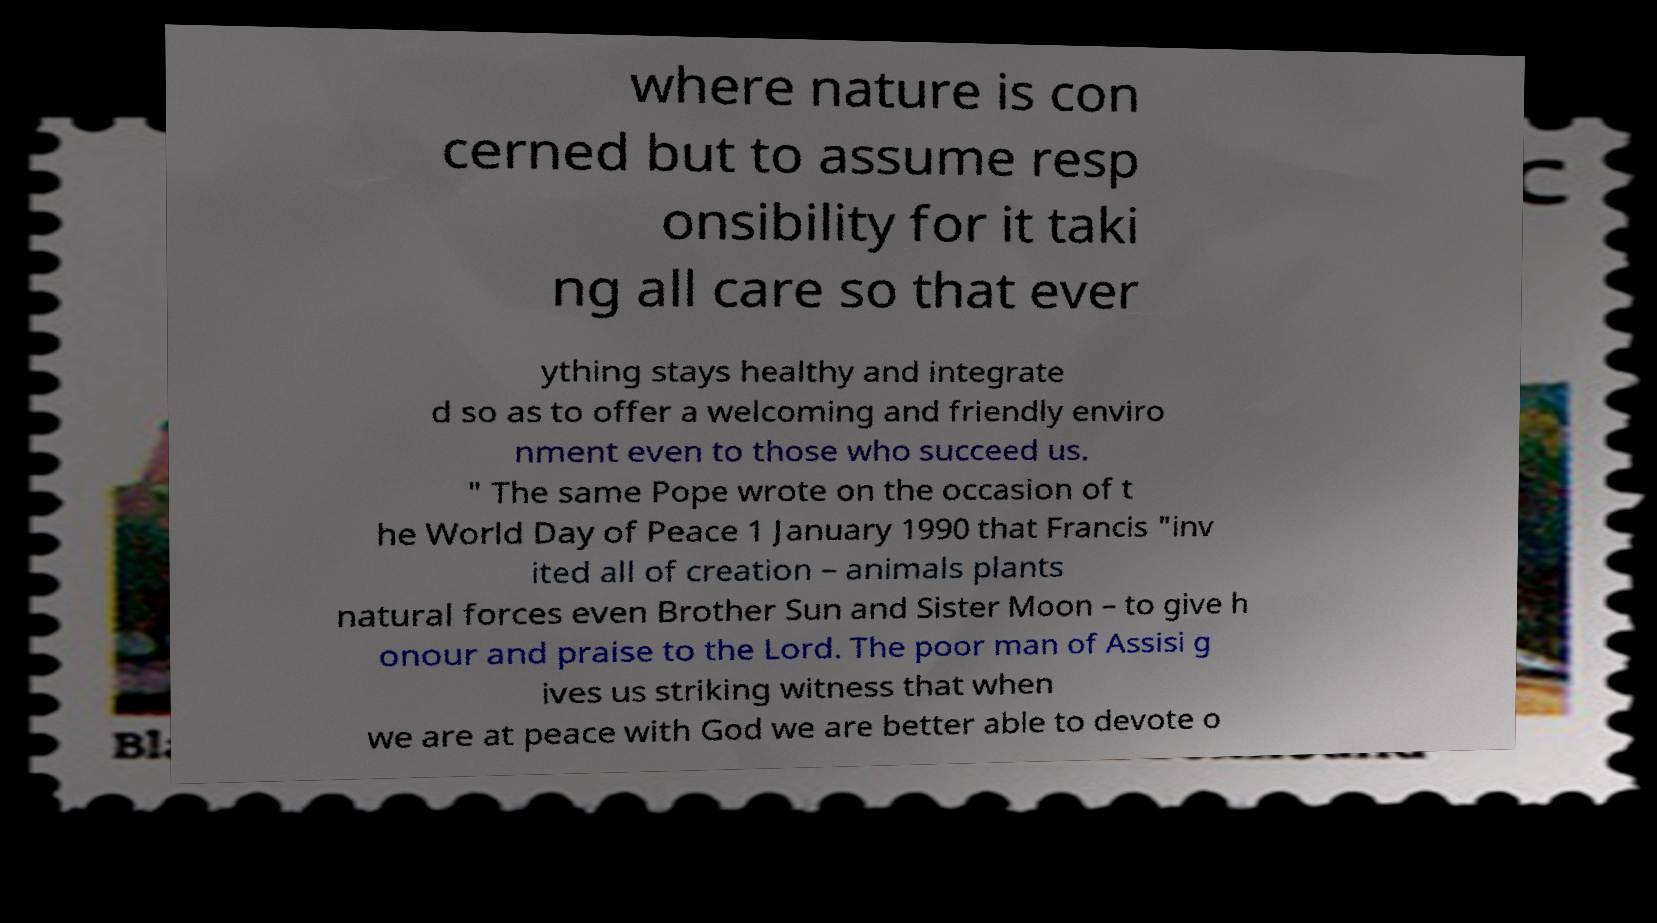Could you extract and type out the text from this image? where nature is con cerned but to assume resp onsibility for it taki ng all care so that ever ything stays healthy and integrate d so as to offer a welcoming and friendly enviro nment even to those who succeed us. " The same Pope wrote on the occasion of t he World Day of Peace 1 January 1990 that Francis "inv ited all of creation – animals plants natural forces even Brother Sun and Sister Moon – to give h onour and praise to the Lord. The poor man of Assisi g ives us striking witness that when we are at peace with God we are better able to devote o 